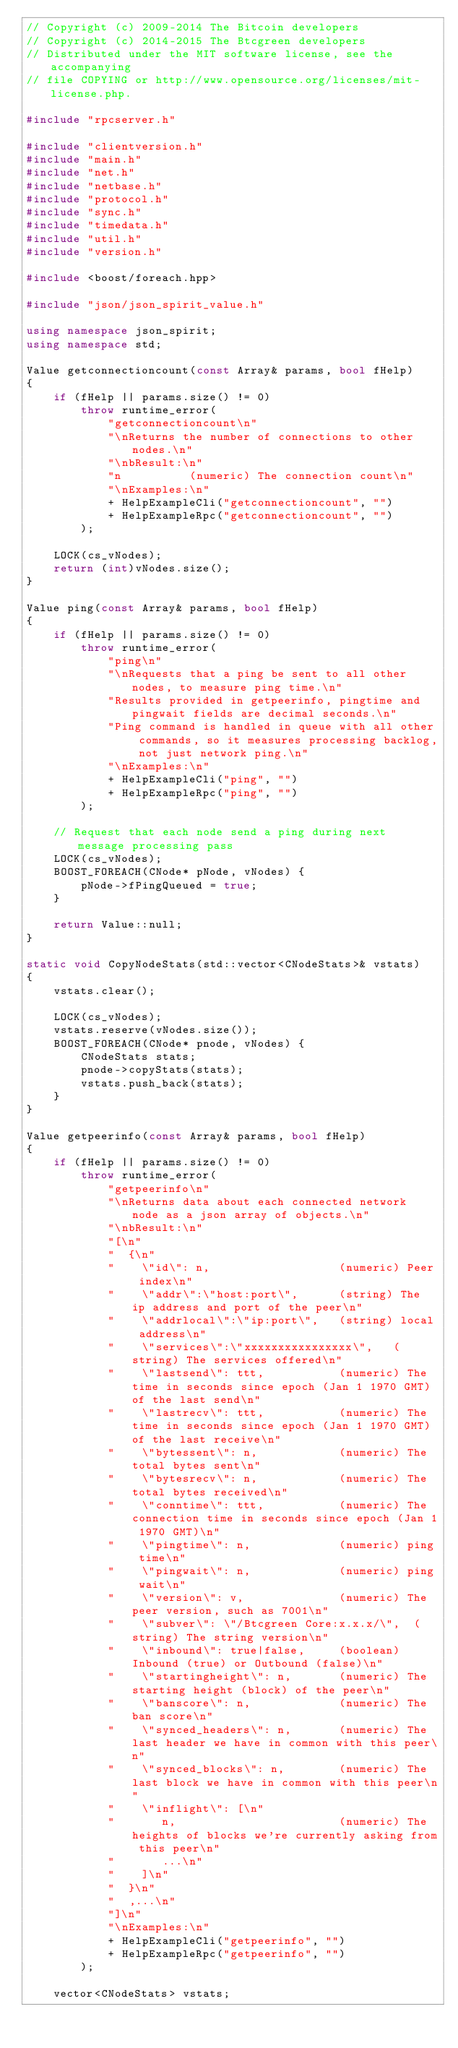Convert code to text. <code><loc_0><loc_0><loc_500><loc_500><_C++_>// Copyright (c) 2009-2014 The Bitcoin developers
// Copyright (c) 2014-2015 The Btcgreen developers
// Distributed under the MIT software license, see the accompanying
// file COPYING or http://www.opensource.org/licenses/mit-license.php.

#include "rpcserver.h"

#include "clientversion.h"
#include "main.h"
#include "net.h"
#include "netbase.h"
#include "protocol.h"
#include "sync.h"
#include "timedata.h"
#include "util.h"
#include "version.h"

#include <boost/foreach.hpp>

#include "json/json_spirit_value.h"

using namespace json_spirit;
using namespace std;

Value getconnectioncount(const Array& params, bool fHelp)
{
    if (fHelp || params.size() != 0)
        throw runtime_error(
            "getconnectioncount\n"
            "\nReturns the number of connections to other nodes.\n"
            "\nbResult:\n"
            "n          (numeric) The connection count\n"
            "\nExamples:\n"
            + HelpExampleCli("getconnectioncount", "")
            + HelpExampleRpc("getconnectioncount", "")
        );

    LOCK(cs_vNodes);
    return (int)vNodes.size();
}

Value ping(const Array& params, bool fHelp)
{
    if (fHelp || params.size() != 0)
        throw runtime_error(
            "ping\n"
            "\nRequests that a ping be sent to all other nodes, to measure ping time.\n"
            "Results provided in getpeerinfo, pingtime and pingwait fields are decimal seconds.\n"
            "Ping command is handled in queue with all other commands, so it measures processing backlog, not just network ping.\n"
            "\nExamples:\n"
            + HelpExampleCli("ping", "")
            + HelpExampleRpc("ping", "")
        );

    // Request that each node send a ping during next message processing pass
    LOCK(cs_vNodes);
    BOOST_FOREACH(CNode* pNode, vNodes) {
        pNode->fPingQueued = true;
    }

    return Value::null;
}

static void CopyNodeStats(std::vector<CNodeStats>& vstats)
{
    vstats.clear();

    LOCK(cs_vNodes);
    vstats.reserve(vNodes.size());
    BOOST_FOREACH(CNode* pnode, vNodes) {
        CNodeStats stats;
        pnode->copyStats(stats);
        vstats.push_back(stats);
    }
}

Value getpeerinfo(const Array& params, bool fHelp)
{
    if (fHelp || params.size() != 0)
        throw runtime_error(
            "getpeerinfo\n"
            "\nReturns data about each connected network node as a json array of objects.\n"
            "\nbResult:\n"
            "[\n"
            "  {\n"
            "    \"id\": n,                   (numeric) Peer index\n"
            "    \"addr\":\"host:port\",      (string) The ip address and port of the peer\n"
            "    \"addrlocal\":\"ip:port\",   (string) local address\n"
            "    \"services\":\"xxxxxxxxxxxxxxxx\",   (string) The services offered\n"
            "    \"lastsend\": ttt,           (numeric) The time in seconds since epoch (Jan 1 1970 GMT) of the last send\n"
            "    \"lastrecv\": ttt,           (numeric) The time in seconds since epoch (Jan 1 1970 GMT) of the last receive\n"
            "    \"bytessent\": n,            (numeric) The total bytes sent\n"
            "    \"bytesrecv\": n,            (numeric) The total bytes received\n"
            "    \"conntime\": ttt,           (numeric) The connection time in seconds since epoch (Jan 1 1970 GMT)\n"
            "    \"pingtime\": n,             (numeric) ping time\n"
            "    \"pingwait\": n,             (numeric) ping wait\n"
            "    \"version\": v,              (numeric) The peer version, such as 7001\n"
            "    \"subver\": \"/Btcgreen Core:x.x.x/\",  (string) The string version\n"
            "    \"inbound\": true|false,     (boolean) Inbound (true) or Outbound (false)\n"
            "    \"startingheight\": n,       (numeric) The starting height (block) of the peer\n"
            "    \"banscore\": n,             (numeric) The ban score\n"
            "    \"synced_headers\": n,       (numeric) The last header we have in common with this peer\n"
            "    \"synced_blocks\": n,        (numeric) The last block we have in common with this peer\n"
            "    \"inflight\": [\n"
            "       n,                        (numeric) The heights of blocks we're currently asking from this peer\n"
            "       ...\n"
            "    ]\n"
            "  }\n"
            "  ,...\n"
            "]\n"
            "\nExamples:\n"
            + HelpExampleCli("getpeerinfo", "")
            + HelpExampleRpc("getpeerinfo", "")
        );

    vector<CNodeStats> vstats;</code> 